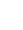<code> <loc_0><loc_0><loc_500><loc_500><_Kotlin_>
</code> 